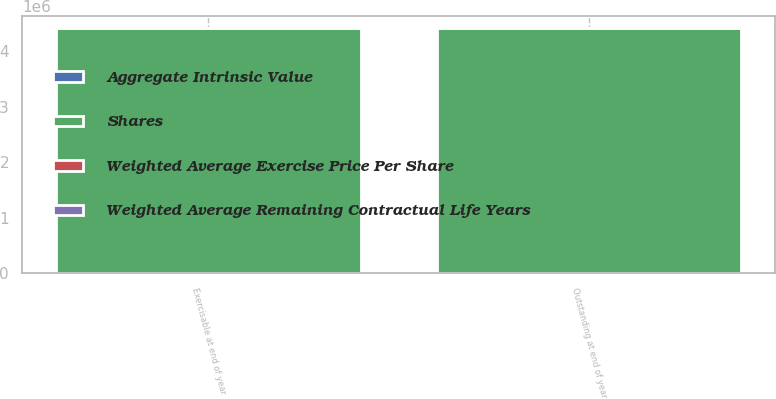<chart> <loc_0><loc_0><loc_500><loc_500><stacked_bar_chart><ecel><fcel>Outstanding at end of year<fcel>Exercisable at end of year<nl><fcel>Shares<fcel>4.41722e+06<fcel>4.41722e+06<nl><fcel>Aggregate Intrinsic Value<fcel>71.69<fcel>71.69<nl><fcel>Weighted Average Exercise Price Per Share<fcel>3.93<fcel>3.93<nl><fcel>Weighted Average Remaining Contractual Life Years<fcel>986<fcel>986<nl></chart> 